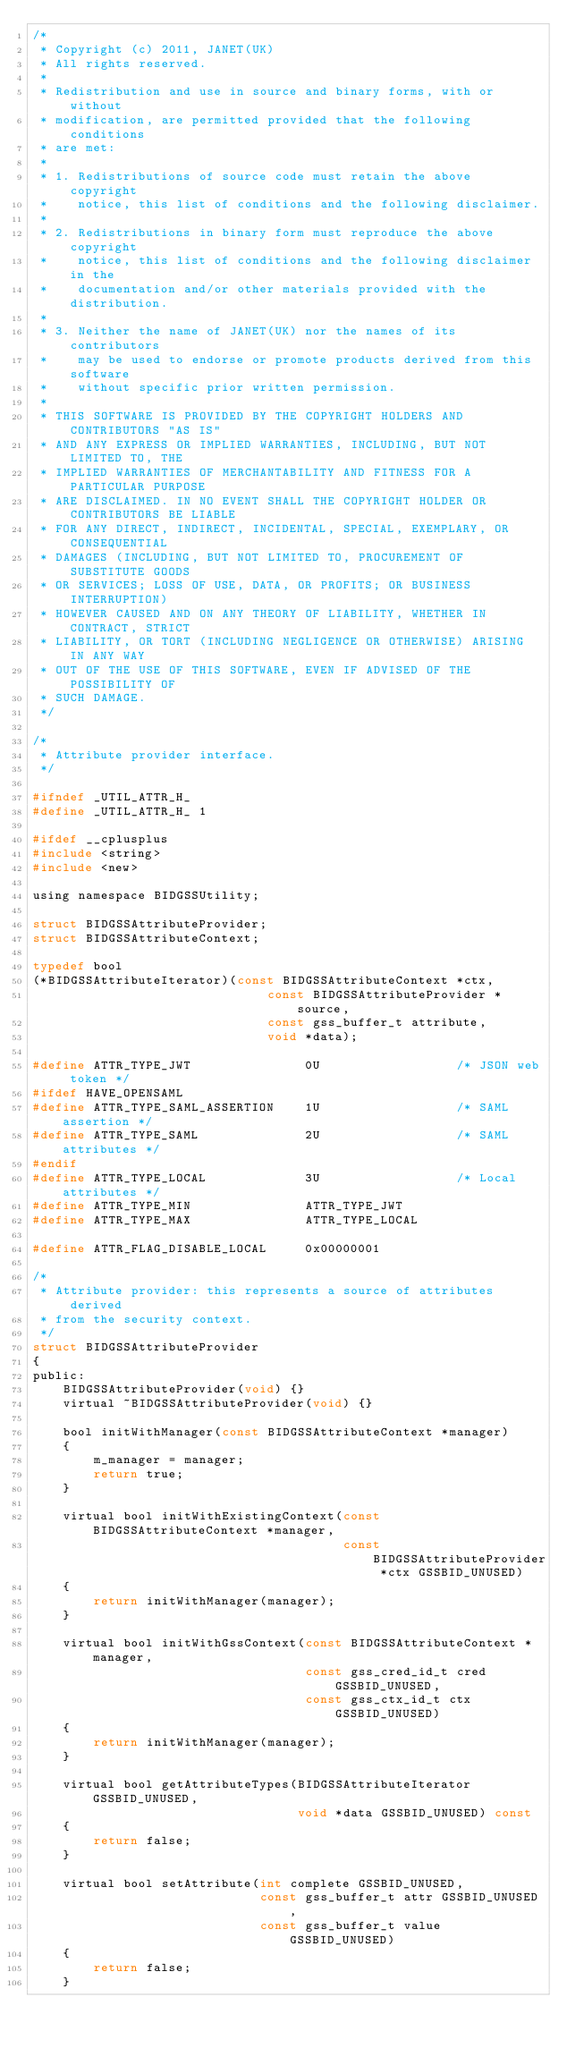Convert code to text. <code><loc_0><loc_0><loc_500><loc_500><_C_>/*
 * Copyright (c) 2011, JANET(UK)
 * All rights reserved.
 *
 * Redistribution and use in source and binary forms, with or without
 * modification, are permitted provided that the following conditions
 * are met:
 *
 * 1. Redistributions of source code must retain the above copyright
 *    notice, this list of conditions and the following disclaimer.
 *
 * 2. Redistributions in binary form must reproduce the above copyright
 *    notice, this list of conditions and the following disclaimer in the
 *    documentation and/or other materials provided with the distribution.
 *
 * 3. Neither the name of JANET(UK) nor the names of its contributors
 *    may be used to endorse or promote products derived from this software
 *    without specific prior written permission.
 *
 * THIS SOFTWARE IS PROVIDED BY THE COPYRIGHT HOLDERS AND CONTRIBUTORS "AS IS"
 * AND ANY EXPRESS OR IMPLIED WARRANTIES, INCLUDING, BUT NOT LIMITED TO, THE
 * IMPLIED WARRANTIES OF MERCHANTABILITY AND FITNESS FOR A PARTICULAR PURPOSE
 * ARE DISCLAIMED. IN NO EVENT SHALL THE COPYRIGHT HOLDER OR CONTRIBUTORS BE LIABLE
 * FOR ANY DIRECT, INDIRECT, INCIDENTAL, SPECIAL, EXEMPLARY, OR CONSEQUENTIAL
 * DAMAGES (INCLUDING, BUT NOT LIMITED TO, PROCUREMENT OF SUBSTITUTE GOODS
 * OR SERVICES; LOSS OF USE, DATA, OR PROFITS; OR BUSINESS INTERRUPTION)
 * HOWEVER CAUSED AND ON ANY THEORY OF LIABILITY, WHETHER IN CONTRACT, STRICT
 * LIABILITY, OR TORT (INCLUDING NEGLIGENCE OR OTHERWISE) ARISING IN ANY WAY
 * OUT OF THE USE OF THIS SOFTWARE, EVEN IF ADVISED OF THE POSSIBILITY OF
 * SUCH DAMAGE.
 */

/*
 * Attribute provider interface.
 */

#ifndef _UTIL_ATTR_H_
#define _UTIL_ATTR_H_ 1

#ifdef __cplusplus
#include <string>
#include <new>

using namespace BIDGSSUtility;

struct BIDGSSAttributeProvider;
struct BIDGSSAttributeContext;

typedef bool
(*BIDGSSAttributeIterator)(const BIDGSSAttributeContext *ctx,
                               const BIDGSSAttributeProvider *source,
                               const gss_buffer_t attribute,
                               void *data);

#define ATTR_TYPE_JWT               0U                  /* JSON web token */
#ifdef HAVE_OPENSAML
#define ATTR_TYPE_SAML_ASSERTION    1U                  /* SAML assertion */
#define ATTR_TYPE_SAML              2U                  /* SAML attributes */
#endif
#define ATTR_TYPE_LOCAL             3U                  /* Local attributes */
#define ATTR_TYPE_MIN               ATTR_TYPE_JWT
#define ATTR_TYPE_MAX               ATTR_TYPE_LOCAL

#define ATTR_FLAG_DISABLE_LOCAL     0x00000001

/*
 * Attribute provider: this represents a source of attributes derived
 * from the security context.
 */
struct BIDGSSAttributeProvider
{
public:
    BIDGSSAttributeProvider(void) {}
    virtual ~BIDGSSAttributeProvider(void) {}

    bool initWithManager(const BIDGSSAttributeContext *manager)
    {
        m_manager = manager;
        return true;
    }

    virtual bool initWithExistingContext(const BIDGSSAttributeContext *manager,
                                         const BIDGSSAttributeProvider *ctx GSSBID_UNUSED)
    {
        return initWithManager(manager);
    }

    virtual bool initWithGssContext(const BIDGSSAttributeContext *manager,
                                    const gss_cred_id_t cred GSSBID_UNUSED,
                                    const gss_ctx_id_t ctx GSSBID_UNUSED)
    {
        return initWithManager(manager);
    }

    virtual bool getAttributeTypes(BIDGSSAttributeIterator GSSBID_UNUSED,
                                   void *data GSSBID_UNUSED) const
    {
        return false;
    }

    virtual bool setAttribute(int complete GSSBID_UNUSED,
                              const gss_buffer_t attr GSSBID_UNUSED,
                              const gss_buffer_t value GSSBID_UNUSED)
    {
        return false;
    }
</code> 